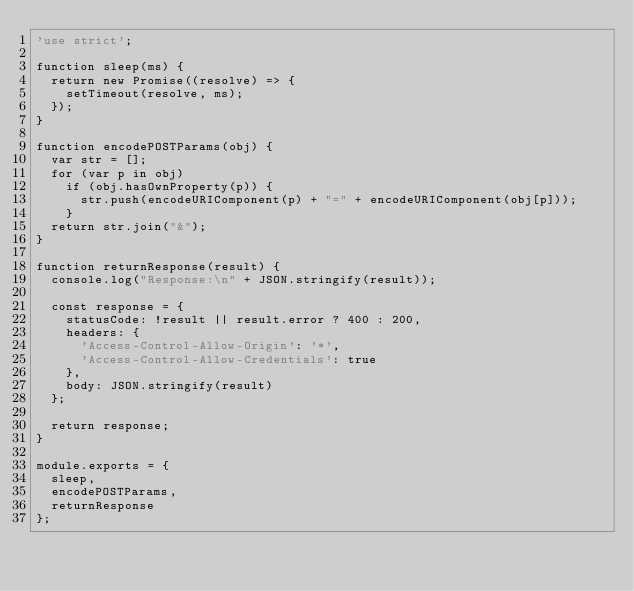<code> <loc_0><loc_0><loc_500><loc_500><_JavaScript_>'use strict';

function sleep(ms) {
  return new Promise((resolve) => {
    setTimeout(resolve, ms);
  });
}

function encodePOSTParams(obj) {
  var str = [];
  for (var p in obj)
    if (obj.hasOwnProperty(p)) {
      str.push(encodeURIComponent(p) + "=" + encodeURIComponent(obj[p]));
    }
  return str.join("&");
}

function returnResponse(result) {
  console.log("Response:\n" + JSON.stringify(result));

  const response = {
    statusCode: !result || result.error ? 400 : 200,
    headers: {
      'Access-Control-Allow-Origin': '*',
      'Access-Control-Allow-Credentials': true
    },
    body: JSON.stringify(result)
  };

  return response;
}

module.exports = {
  sleep,
  encodePOSTParams,
  returnResponse
};
</code> 